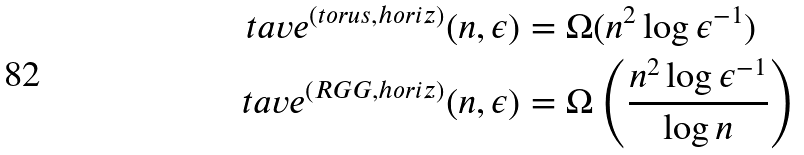Convert formula to latex. <formula><loc_0><loc_0><loc_500><loc_500>\ t a v e ^ { ( t o r u s , h o r i z ) } ( n , \epsilon ) & = \Omega ( n ^ { 2 } \log \epsilon ^ { - 1 } ) \\ \ t a v e ^ { ( R G G , h o r i z ) } ( n , \epsilon ) & = \Omega \left ( \frac { n ^ { 2 } \log \epsilon ^ { - 1 } } { \log n } \right )</formula> 